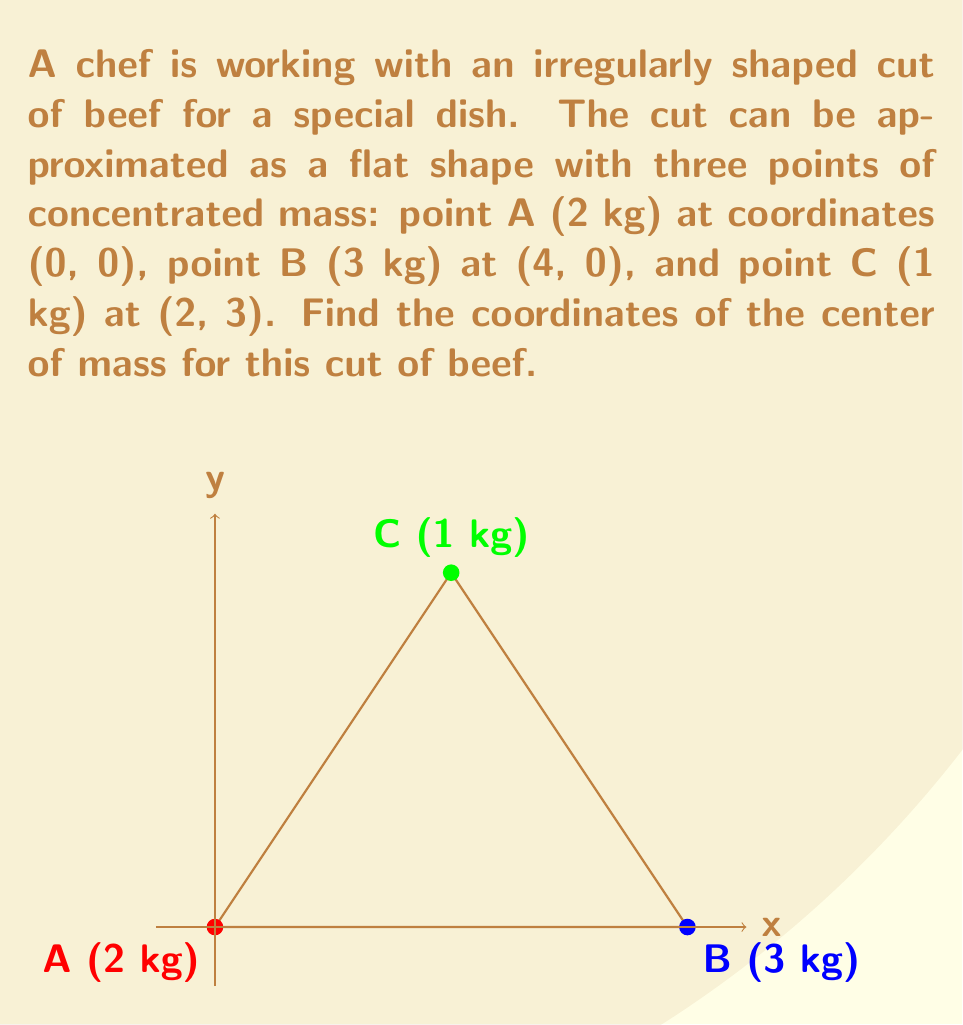Show me your answer to this math problem. To find the center of mass of this irregularly shaped cut of beef, we'll use vector calculations. Let's approach this step-by-step:

1) The center of mass formula for a system of particles is:

   $$\vec{r}_{cm} = \frac{\sum_{i} m_i \vec{r}_i}{\sum_{i} m_i}$$

   where $m_i$ is the mass of each particle and $\vec{r}_i$ is its position vector.

2) First, let's calculate the total mass:
   
   $M_{total} = 2 + 3 + 1 = 6$ kg

3) Now, let's calculate the numerator of the formula for x and y coordinates separately:

   For x-coordinate:
   $$x_{cm} = \frac{2(0) + 3(4) + 1(2)}{6} = \frac{12 + 2}{6} = \frac{14}{6}$$

   For y-coordinate:
   $$y_{cm} = \frac{2(0) + 3(0) + 1(3)}{6} = \frac{3}{6} = \frac{1}{2}$$

4) Therefore, the center of mass is located at:

   $$\vec{r}_{cm} = (\frac{14}{6}, \frac{1}{2})$$

5) Simplifying the x-coordinate:
   
   $$\frac{14}{6} = \frac{7}{3} \approx 2.33$$

So, the final coordinates of the center of mass are approximately (2.33, 0.5).
Answer: $(\frac{7}{3}, \frac{1}{2})$ or approximately (2.33, 0.5) 